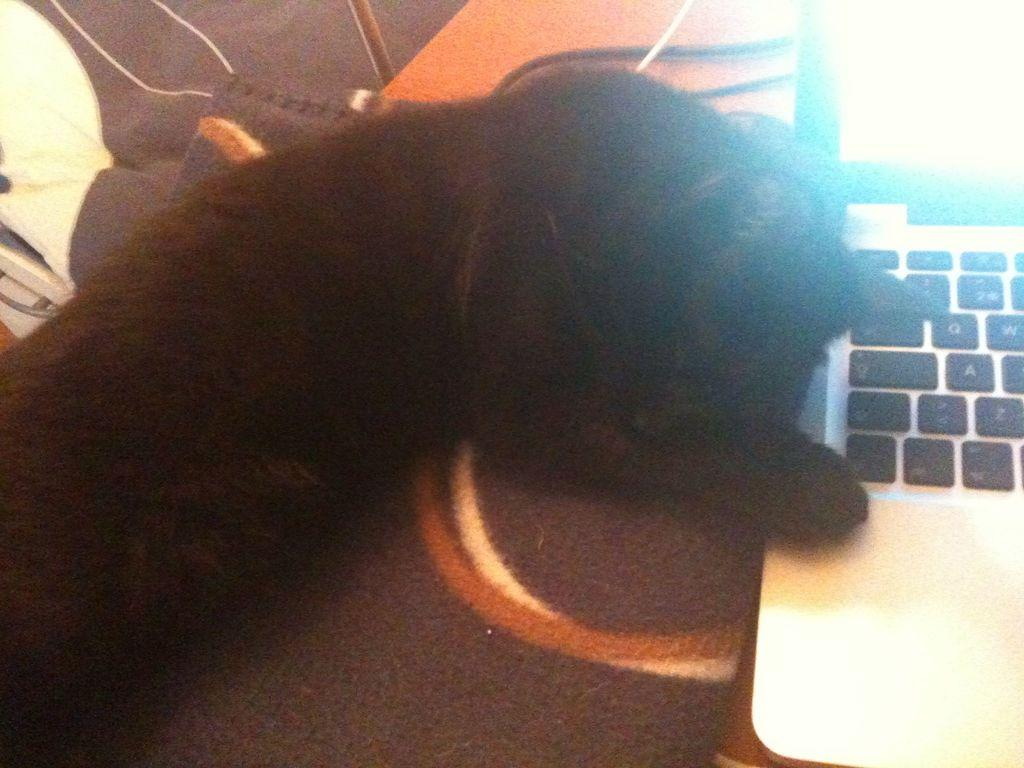What type of animal is in the image? There is a dog in the image. What electronic device is in the image? There is a laptop in the image. Where are the dog and laptop located in the image? The dog and laptop are on a surface. What type of yam is being used as a pillow for the dog in the image? There is no yam present in the image, and the dog is not using a pillow. 